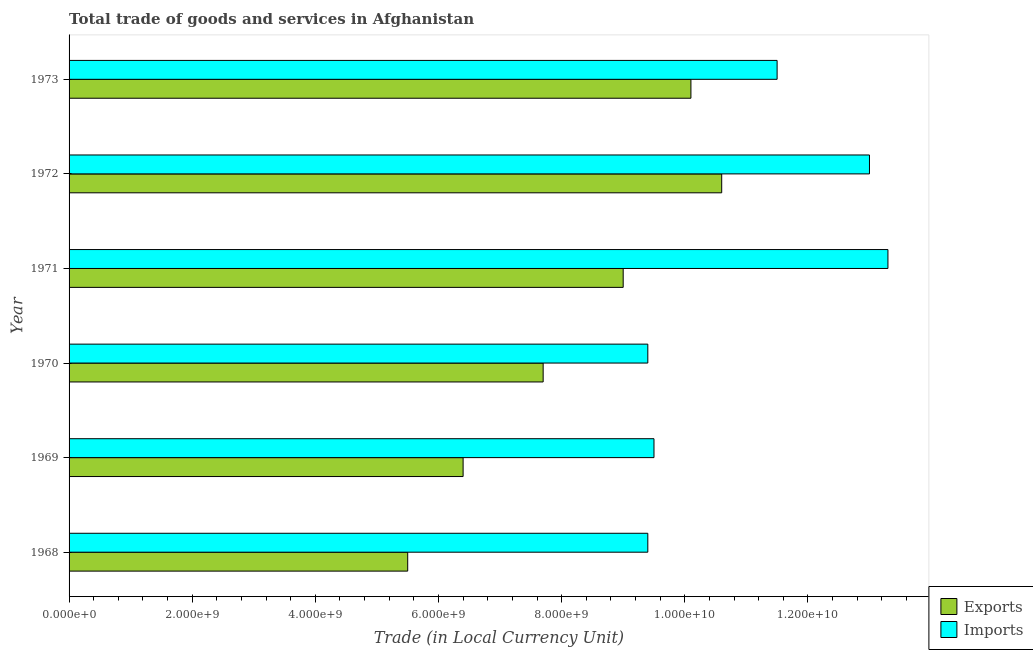How many different coloured bars are there?
Ensure brevity in your answer.  2. Are the number of bars per tick equal to the number of legend labels?
Your answer should be very brief. Yes. Are the number of bars on each tick of the Y-axis equal?
Make the answer very short. Yes. How many bars are there on the 3rd tick from the top?
Keep it short and to the point. 2. How many bars are there on the 4th tick from the bottom?
Provide a short and direct response. 2. What is the label of the 1st group of bars from the top?
Ensure brevity in your answer.  1973. What is the export of goods and services in 1968?
Your answer should be compact. 5.50e+09. Across all years, what is the maximum imports of goods and services?
Keep it short and to the point. 1.33e+1. Across all years, what is the minimum export of goods and services?
Your response must be concise. 5.50e+09. In which year was the export of goods and services maximum?
Your response must be concise. 1972. In which year was the imports of goods and services minimum?
Your answer should be very brief. 1968. What is the total export of goods and services in the graph?
Offer a very short reply. 4.93e+1. What is the difference between the export of goods and services in 1969 and that in 1971?
Provide a succinct answer. -2.60e+09. What is the difference between the imports of goods and services in 1969 and the export of goods and services in 1971?
Make the answer very short. 5.00e+08. What is the average imports of goods and services per year?
Give a very brief answer. 1.10e+1. In the year 1970, what is the difference between the export of goods and services and imports of goods and services?
Give a very brief answer. -1.70e+09. What is the ratio of the export of goods and services in 1971 to that in 1973?
Ensure brevity in your answer.  0.89. Is the export of goods and services in 1972 less than that in 1973?
Provide a short and direct response. No. Is the difference between the imports of goods and services in 1968 and 1969 greater than the difference between the export of goods and services in 1968 and 1969?
Provide a succinct answer. Yes. What is the difference between the highest and the second highest export of goods and services?
Offer a very short reply. 5.00e+08. What is the difference between the highest and the lowest export of goods and services?
Give a very brief answer. 5.10e+09. What does the 1st bar from the top in 1969 represents?
Offer a very short reply. Imports. What does the 1st bar from the bottom in 1969 represents?
Your response must be concise. Exports. How many bars are there?
Provide a succinct answer. 12. Are all the bars in the graph horizontal?
Keep it short and to the point. Yes. What is the difference between two consecutive major ticks on the X-axis?
Keep it short and to the point. 2.00e+09. Does the graph contain grids?
Give a very brief answer. No. Where does the legend appear in the graph?
Keep it short and to the point. Bottom right. How many legend labels are there?
Give a very brief answer. 2. How are the legend labels stacked?
Make the answer very short. Vertical. What is the title of the graph?
Give a very brief answer. Total trade of goods and services in Afghanistan. What is the label or title of the X-axis?
Ensure brevity in your answer.  Trade (in Local Currency Unit). What is the label or title of the Y-axis?
Your response must be concise. Year. What is the Trade (in Local Currency Unit) of Exports in 1968?
Provide a succinct answer. 5.50e+09. What is the Trade (in Local Currency Unit) of Imports in 1968?
Offer a terse response. 9.40e+09. What is the Trade (in Local Currency Unit) in Exports in 1969?
Your answer should be compact. 6.40e+09. What is the Trade (in Local Currency Unit) in Imports in 1969?
Offer a very short reply. 9.50e+09. What is the Trade (in Local Currency Unit) in Exports in 1970?
Keep it short and to the point. 7.70e+09. What is the Trade (in Local Currency Unit) of Imports in 1970?
Your answer should be compact. 9.40e+09. What is the Trade (in Local Currency Unit) in Exports in 1971?
Keep it short and to the point. 9.00e+09. What is the Trade (in Local Currency Unit) of Imports in 1971?
Make the answer very short. 1.33e+1. What is the Trade (in Local Currency Unit) in Exports in 1972?
Provide a succinct answer. 1.06e+1. What is the Trade (in Local Currency Unit) of Imports in 1972?
Offer a terse response. 1.30e+1. What is the Trade (in Local Currency Unit) in Exports in 1973?
Make the answer very short. 1.01e+1. What is the Trade (in Local Currency Unit) in Imports in 1973?
Provide a short and direct response. 1.15e+1. Across all years, what is the maximum Trade (in Local Currency Unit) of Exports?
Make the answer very short. 1.06e+1. Across all years, what is the maximum Trade (in Local Currency Unit) in Imports?
Keep it short and to the point. 1.33e+1. Across all years, what is the minimum Trade (in Local Currency Unit) in Exports?
Your answer should be very brief. 5.50e+09. Across all years, what is the minimum Trade (in Local Currency Unit) in Imports?
Offer a very short reply. 9.40e+09. What is the total Trade (in Local Currency Unit) of Exports in the graph?
Offer a terse response. 4.93e+1. What is the total Trade (in Local Currency Unit) of Imports in the graph?
Your response must be concise. 6.61e+1. What is the difference between the Trade (in Local Currency Unit) of Exports in 1968 and that in 1969?
Make the answer very short. -9.00e+08. What is the difference between the Trade (in Local Currency Unit) of Imports in 1968 and that in 1969?
Offer a terse response. -1.00e+08. What is the difference between the Trade (in Local Currency Unit) in Exports in 1968 and that in 1970?
Give a very brief answer. -2.20e+09. What is the difference between the Trade (in Local Currency Unit) of Exports in 1968 and that in 1971?
Ensure brevity in your answer.  -3.50e+09. What is the difference between the Trade (in Local Currency Unit) in Imports in 1968 and that in 1971?
Your response must be concise. -3.90e+09. What is the difference between the Trade (in Local Currency Unit) in Exports in 1968 and that in 1972?
Your response must be concise. -5.10e+09. What is the difference between the Trade (in Local Currency Unit) of Imports in 1968 and that in 1972?
Provide a short and direct response. -3.60e+09. What is the difference between the Trade (in Local Currency Unit) in Exports in 1968 and that in 1973?
Keep it short and to the point. -4.60e+09. What is the difference between the Trade (in Local Currency Unit) in Imports in 1968 and that in 1973?
Ensure brevity in your answer.  -2.10e+09. What is the difference between the Trade (in Local Currency Unit) of Exports in 1969 and that in 1970?
Your answer should be compact. -1.30e+09. What is the difference between the Trade (in Local Currency Unit) of Imports in 1969 and that in 1970?
Make the answer very short. 1.00e+08. What is the difference between the Trade (in Local Currency Unit) in Exports in 1969 and that in 1971?
Your response must be concise. -2.60e+09. What is the difference between the Trade (in Local Currency Unit) of Imports in 1969 and that in 1971?
Keep it short and to the point. -3.80e+09. What is the difference between the Trade (in Local Currency Unit) in Exports in 1969 and that in 1972?
Give a very brief answer. -4.20e+09. What is the difference between the Trade (in Local Currency Unit) of Imports in 1969 and that in 1972?
Offer a very short reply. -3.50e+09. What is the difference between the Trade (in Local Currency Unit) of Exports in 1969 and that in 1973?
Keep it short and to the point. -3.70e+09. What is the difference between the Trade (in Local Currency Unit) of Imports in 1969 and that in 1973?
Keep it short and to the point. -2.00e+09. What is the difference between the Trade (in Local Currency Unit) in Exports in 1970 and that in 1971?
Your answer should be very brief. -1.30e+09. What is the difference between the Trade (in Local Currency Unit) of Imports in 1970 and that in 1971?
Give a very brief answer. -3.90e+09. What is the difference between the Trade (in Local Currency Unit) of Exports in 1970 and that in 1972?
Provide a short and direct response. -2.90e+09. What is the difference between the Trade (in Local Currency Unit) in Imports in 1970 and that in 1972?
Your answer should be compact. -3.60e+09. What is the difference between the Trade (in Local Currency Unit) in Exports in 1970 and that in 1973?
Offer a very short reply. -2.40e+09. What is the difference between the Trade (in Local Currency Unit) in Imports in 1970 and that in 1973?
Your response must be concise. -2.10e+09. What is the difference between the Trade (in Local Currency Unit) of Exports in 1971 and that in 1972?
Keep it short and to the point. -1.60e+09. What is the difference between the Trade (in Local Currency Unit) of Imports in 1971 and that in 1972?
Provide a succinct answer. 3.00e+08. What is the difference between the Trade (in Local Currency Unit) in Exports in 1971 and that in 1973?
Offer a very short reply. -1.10e+09. What is the difference between the Trade (in Local Currency Unit) of Imports in 1971 and that in 1973?
Make the answer very short. 1.80e+09. What is the difference between the Trade (in Local Currency Unit) of Exports in 1972 and that in 1973?
Provide a short and direct response. 5.00e+08. What is the difference between the Trade (in Local Currency Unit) of Imports in 1972 and that in 1973?
Provide a short and direct response. 1.50e+09. What is the difference between the Trade (in Local Currency Unit) in Exports in 1968 and the Trade (in Local Currency Unit) in Imports in 1969?
Provide a succinct answer. -4.00e+09. What is the difference between the Trade (in Local Currency Unit) in Exports in 1968 and the Trade (in Local Currency Unit) in Imports in 1970?
Ensure brevity in your answer.  -3.90e+09. What is the difference between the Trade (in Local Currency Unit) of Exports in 1968 and the Trade (in Local Currency Unit) of Imports in 1971?
Offer a terse response. -7.80e+09. What is the difference between the Trade (in Local Currency Unit) of Exports in 1968 and the Trade (in Local Currency Unit) of Imports in 1972?
Your response must be concise. -7.50e+09. What is the difference between the Trade (in Local Currency Unit) in Exports in 1968 and the Trade (in Local Currency Unit) in Imports in 1973?
Your answer should be compact. -6.00e+09. What is the difference between the Trade (in Local Currency Unit) in Exports in 1969 and the Trade (in Local Currency Unit) in Imports in 1970?
Your answer should be very brief. -3.00e+09. What is the difference between the Trade (in Local Currency Unit) in Exports in 1969 and the Trade (in Local Currency Unit) in Imports in 1971?
Offer a very short reply. -6.90e+09. What is the difference between the Trade (in Local Currency Unit) in Exports in 1969 and the Trade (in Local Currency Unit) in Imports in 1972?
Make the answer very short. -6.60e+09. What is the difference between the Trade (in Local Currency Unit) in Exports in 1969 and the Trade (in Local Currency Unit) in Imports in 1973?
Make the answer very short. -5.10e+09. What is the difference between the Trade (in Local Currency Unit) in Exports in 1970 and the Trade (in Local Currency Unit) in Imports in 1971?
Make the answer very short. -5.60e+09. What is the difference between the Trade (in Local Currency Unit) in Exports in 1970 and the Trade (in Local Currency Unit) in Imports in 1972?
Your answer should be compact. -5.30e+09. What is the difference between the Trade (in Local Currency Unit) in Exports in 1970 and the Trade (in Local Currency Unit) in Imports in 1973?
Give a very brief answer. -3.80e+09. What is the difference between the Trade (in Local Currency Unit) of Exports in 1971 and the Trade (in Local Currency Unit) of Imports in 1972?
Offer a terse response. -4.00e+09. What is the difference between the Trade (in Local Currency Unit) in Exports in 1971 and the Trade (in Local Currency Unit) in Imports in 1973?
Ensure brevity in your answer.  -2.50e+09. What is the difference between the Trade (in Local Currency Unit) in Exports in 1972 and the Trade (in Local Currency Unit) in Imports in 1973?
Offer a very short reply. -9.00e+08. What is the average Trade (in Local Currency Unit) of Exports per year?
Keep it short and to the point. 8.22e+09. What is the average Trade (in Local Currency Unit) in Imports per year?
Offer a terse response. 1.10e+1. In the year 1968, what is the difference between the Trade (in Local Currency Unit) of Exports and Trade (in Local Currency Unit) of Imports?
Provide a short and direct response. -3.90e+09. In the year 1969, what is the difference between the Trade (in Local Currency Unit) of Exports and Trade (in Local Currency Unit) of Imports?
Make the answer very short. -3.10e+09. In the year 1970, what is the difference between the Trade (in Local Currency Unit) in Exports and Trade (in Local Currency Unit) in Imports?
Ensure brevity in your answer.  -1.70e+09. In the year 1971, what is the difference between the Trade (in Local Currency Unit) in Exports and Trade (in Local Currency Unit) in Imports?
Offer a terse response. -4.30e+09. In the year 1972, what is the difference between the Trade (in Local Currency Unit) of Exports and Trade (in Local Currency Unit) of Imports?
Give a very brief answer. -2.40e+09. In the year 1973, what is the difference between the Trade (in Local Currency Unit) of Exports and Trade (in Local Currency Unit) of Imports?
Your response must be concise. -1.40e+09. What is the ratio of the Trade (in Local Currency Unit) of Exports in 1968 to that in 1969?
Give a very brief answer. 0.86. What is the ratio of the Trade (in Local Currency Unit) of Exports in 1968 to that in 1970?
Offer a very short reply. 0.71. What is the ratio of the Trade (in Local Currency Unit) of Exports in 1968 to that in 1971?
Ensure brevity in your answer.  0.61. What is the ratio of the Trade (in Local Currency Unit) of Imports in 1968 to that in 1971?
Ensure brevity in your answer.  0.71. What is the ratio of the Trade (in Local Currency Unit) of Exports in 1968 to that in 1972?
Provide a short and direct response. 0.52. What is the ratio of the Trade (in Local Currency Unit) in Imports in 1968 to that in 1972?
Offer a terse response. 0.72. What is the ratio of the Trade (in Local Currency Unit) of Exports in 1968 to that in 1973?
Ensure brevity in your answer.  0.54. What is the ratio of the Trade (in Local Currency Unit) of Imports in 1968 to that in 1973?
Make the answer very short. 0.82. What is the ratio of the Trade (in Local Currency Unit) in Exports in 1969 to that in 1970?
Your answer should be compact. 0.83. What is the ratio of the Trade (in Local Currency Unit) of Imports in 1969 to that in 1970?
Provide a short and direct response. 1.01. What is the ratio of the Trade (in Local Currency Unit) of Exports in 1969 to that in 1971?
Offer a terse response. 0.71. What is the ratio of the Trade (in Local Currency Unit) in Exports in 1969 to that in 1972?
Make the answer very short. 0.6. What is the ratio of the Trade (in Local Currency Unit) in Imports in 1969 to that in 1972?
Offer a very short reply. 0.73. What is the ratio of the Trade (in Local Currency Unit) of Exports in 1969 to that in 1973?
Your response must be concise. 0.63. What is the ratio of the Trade (in Local Currency Unit) in Imports in 1969 to that in 1973?
Ensure brevity in your answer.  0.83. What is the ratio of the Trade (in Local Currency Unit) of Exports in 1970 to that in 1971?
Keep it short and to the point. 0.86. What is the ratio of the Trade (in Local Currency Unit) in Imports in 1970 to that in 1971?
Ensure brevity in your answer.  0.71. What is the ratio of the Trade (in Local Currency Unit) in Exports in 1970 to that in 1972?
Provide a short and direct response. 0.73. What is the ratio of the Trade (in Local Currency Unit) in Imports in 1970 to that in 1972?
Offer a terse response. 0.72. What is the ratio of the Trade (in Local Currency Unit) in Exports in 1970 to that in 1973?
Your answer should be very brief. 0.76. What is the ratio of the Trade (in Local Currency Unit) in Imports in 1970 to that in 1973?
Provide a succinct answer. 0.82. What is the ratio of the Trade (in Local Currency Unit) in Exports in 1971 to that in 1972?
Ensure brevity in your answer.  0.85. What is the ratio of the Trade (in Local Currency Unit) of Imports in 1971 to that in 1972?
Your answer should be compact. 1.02. What is the ratio of the Trade (in Local Currency Unit) of Exports in 1971 to that in 1973?
Provide a succinct answer. 0.89. What is the ratio of the Trade (in Local Currency Unit) of Imports in 1971 to that in 1973?
Provide a succinct answer. 1.16. What is the ratio of the Trade (in Local Currency Unit) of Exports in 1972 to that in 1973?
Provide a succinct answer. 1.05. What is the ratio of the Trade (in Local Currency Unit) of Imports in 1972 to that in 1973?
Ensure brevity in your answer.  1.13. What is the difference between the highest and the second highest Trade (in Local Currency Unit) in Exports?
Offer a very short reply. 5.00e+08. What is the difference between the highest and the second highest Trade (in Local Currency Unit) of Imports?
Provide a succinct answer. 3.00e+08. What is the difference between the highest and the lowest Trade (in Local Currency Unit) of Exports?
Give a very brief answer. 5.10e+09. What is the difference between the highest and the lowest Trade (in Local Currency Unit) of Imports?
Give a very brief answer. 3.90e+09. 